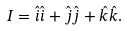<formula> <loc_0><loc_0><loc_500><loc_500>I = \hat { i } \hat { i } + \hat { j } \hat { j } + \hat { k } \hat { k } .</formula> 